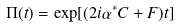Convert formula to latex. <formula><loc_0><loc_0><loc_500><loc_500>\Pi ( t ) = \exp [ ( 2 i \alpha ^ { * } C + F ) t ]</formula> 